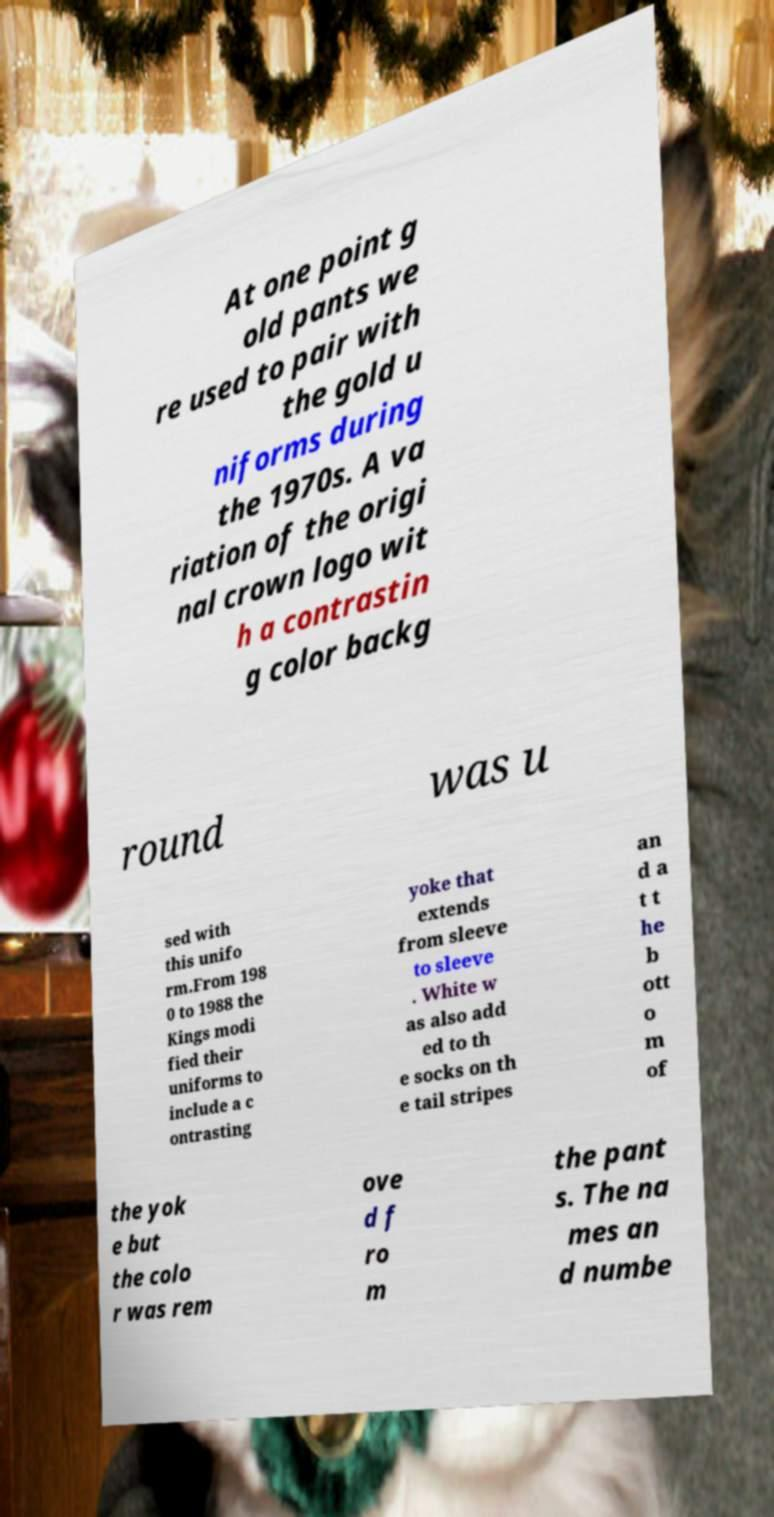Please read and relay the text visible in this image. What does it say? At one point g old pants we re used to pair with the gold u niforms during the 1970s. A va riation of the origi nal crown logo wit h a contrastin g color backg round was u sed with this unifo rm.From 198 0 to 1988 the Kings modi fied their uniforms to include a c ontrasting yoke that extends from sleeve to sleeve . White w as also add ed to th e socks on th e tail stripes an d a t t he b ott o m of the yok e but the colo r was rem ove d f ro m the pant s. The na mes an d numbe 